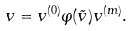<formula> <loc_0><loc_0><loc_500><loc_500>v = v ^ { ( 0 ) } \varphi ( \tilde { v } ) v ^ { ( m ) } .</formula> 